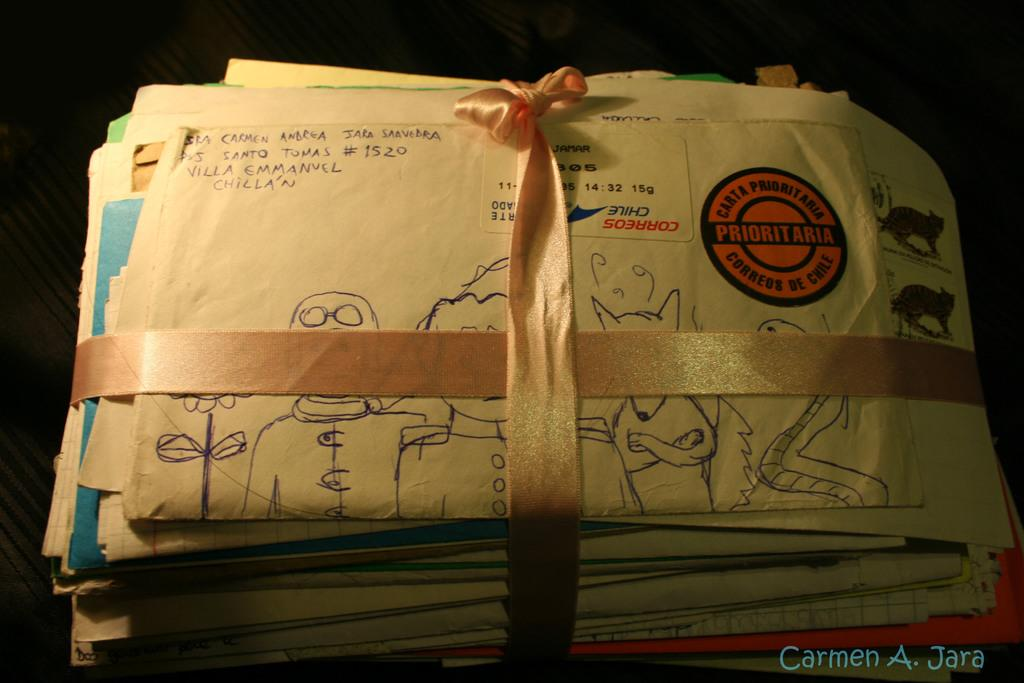<image>
Describe the image concisely. A stack of letters is tied with a ribbon, the top letter has a return address of Santo Tomas #1520, Villa Emmanuel Chillain. 